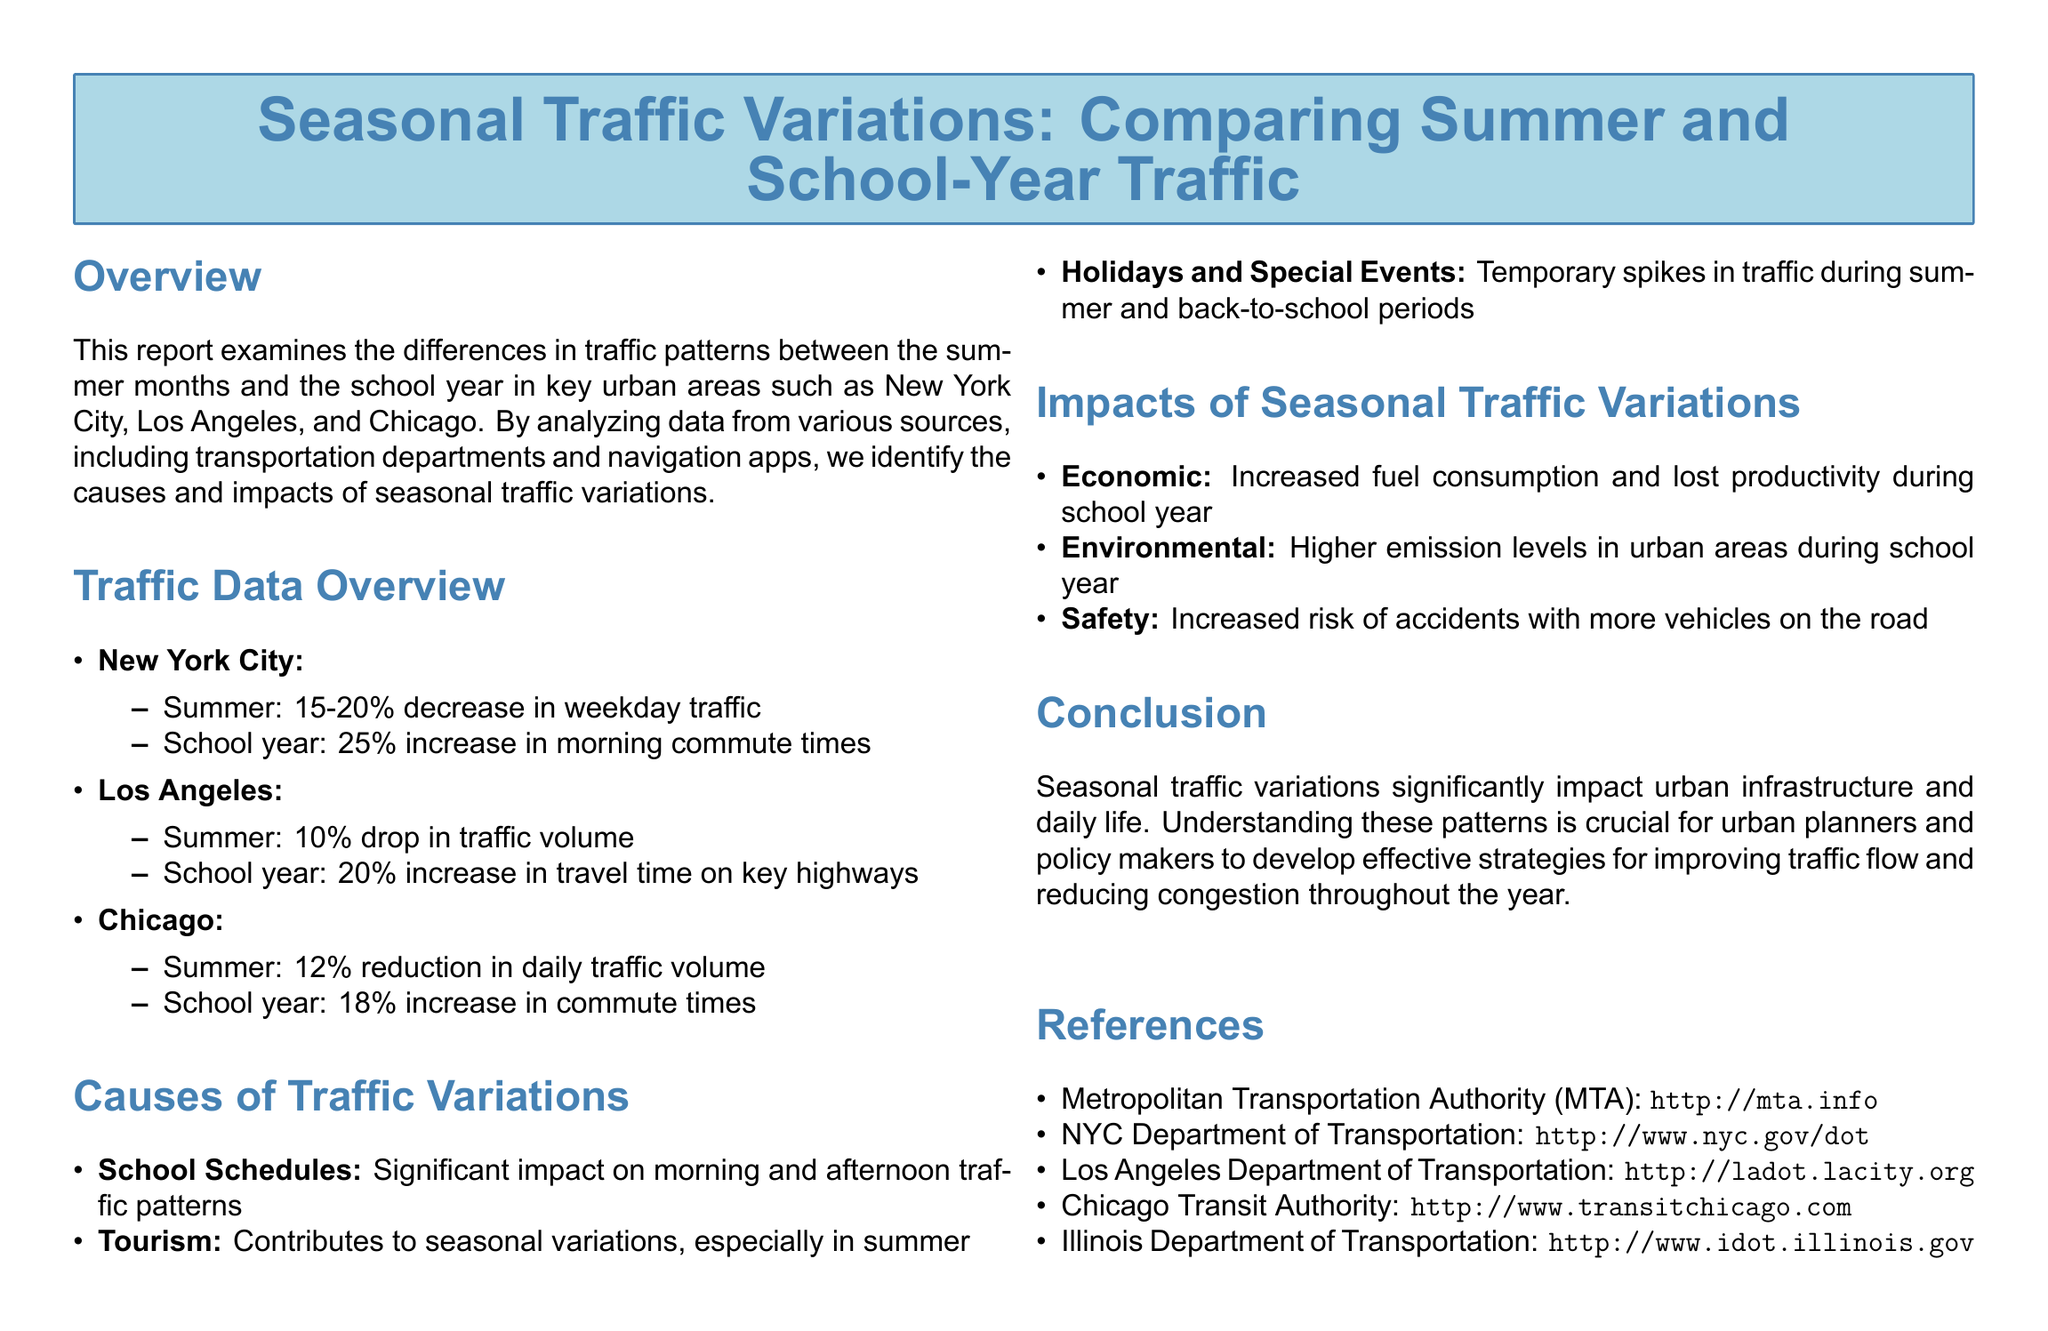What is the decrease in weekday traffic in New York City during summer? New York City experiences a 15-20% decrease in weekday traffic during the summer months.
Answer: 15-20% What is the increase in morning commute times during the school year in Chicago? During the school year, Chicago sees an 18% increase in commute times.
Answer: 18% What contributes to seasonal traffic variations, particularly in summer? Tourism is a significant factor that contributes to traffic variations during summer.
Answer: Tourism What is the reported increase in travel time on key highways in Los Angeles during the school year? Los Angeles experiences a 20% increase in travel time on key highways during the school year.
Answer: 20% What is the economic impact of seasonal traffic variations mentioned in the report? The economic impact includes increased fuel consumption and lost productivity during the school year.
Answer: Increased fuel consumption and lost productivity What causes significant changes in traffic patterns according to the document? School schedules have a significant impact on traffic patterns during the school year.
Answer: School schedules What percentage decrease in daily traffic volume is noted in Chicago during summer? Chicago reports a 12% reduction in daily traffic volume during the summer.
Answer: 12% What kind of spikes in traffic occur during the summer according to the report? Temporary spikes in traffic occur during holidays and special events in summer.
Answer: Temporary spikes What is a key safety concern mentioned during the school year traffic increases? Increased risk of accidents is a key safety concern during the school year.
Answer: Increased risk of accidents 